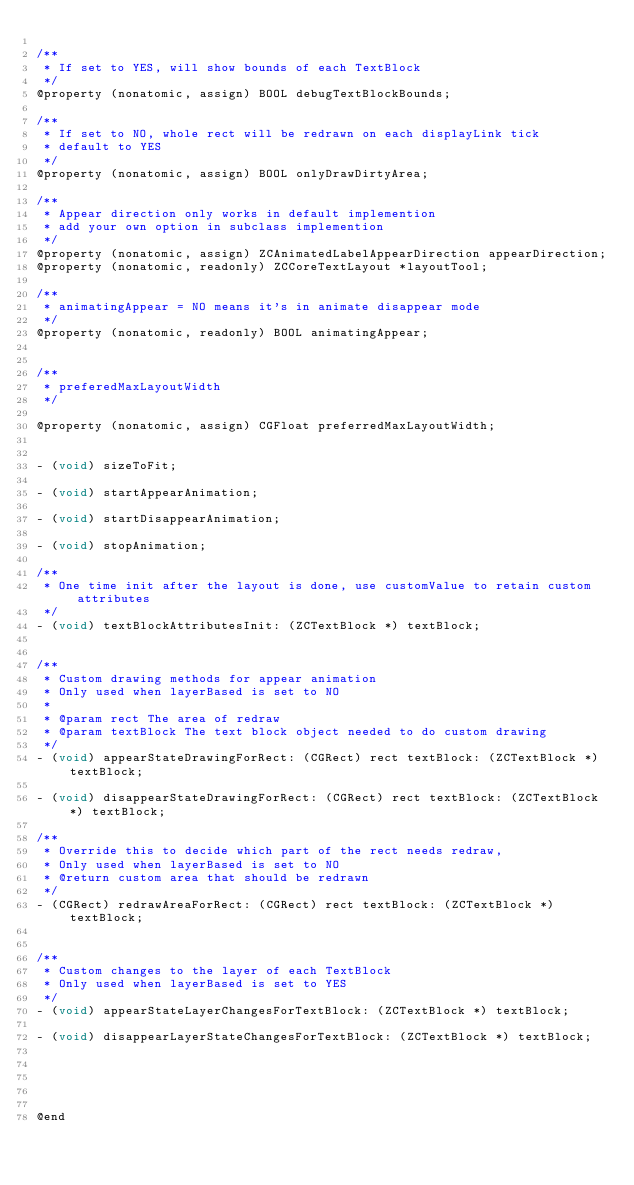Convert code to text. <code><loc_0><loc_0><loc_500><loc_500><_C_>
/**
 * If set to YES, will show bounds of each TextBlock
 */
@property (nonatomic, assign) BOOL debugTextBlockBounds;

/**
 * If set to NO, whole rect will be redrawn on each displayLink tick
 * default to YES
 */
@property (nonatomic, assign) BOOL onlyDrawDirtyArea;

/**
 * Appear direction only works in default implemention
 * add your own option in subclass implemention
 */
@property (nonatomic, assign) ZCAnimatedLabelAppearDirection appearDirection;
@property (nonatomic, readonly) ZCCoreTextLayout *layoutTool;

/**
 * animatingAppear = NO means it's in animate disappear mode
 */
@property (nonatomic, readonly) BOOL animatingAppear;


/**
 * preferedMaxLayoutWidth
 */

@property (nonatomic, assign) CGFloat preferredMaxLayoutWidth;


- (void) sizeToFit;

- (void) startAppearAnimation;

- (void) startDisappearAnimation;

- (void) stopAnimation;

/**
 * One time init after the layout is done, use customValue to retain custom attributes
 */
- (void) textBlockAttributesInit: (ZCTextBlock *) textBlock;


/**
 * Custom drawing methods for appear animation
 * Only used when layerBased is set to NO
 *
 * @param rect The area of redraw
 * @param textBlock The text block object needed to do custom drawing
 */
- (void) appearStateDrawingForRect: (CGRect) rect textBlock: (ZCTextBlock *) textBlock;

- (void) disappearStateDrawingForRect: (CGRect) rect textBlock: (ZCTextBlock *) textBlock;

/**
 * Override this to decide which part of the rect needs redraw,
 * Only used when layerBased is set to NO
 * @return custom area that should be redrawn
 */
- (CGRect) redrawAreaForRect: (CGRect) rect textBlock: (ZCTextBlock *) textBlock;


/**
 * Custom changes to the layer of each TextBlock
 * Only used when layerBased is set to YES
 */
- (void) appearStateLayerChangesForTextBlock: (ZCTextBlock *) textBlock;

- (void) disappearLayerStateChangesForTextBlock: (ZCTextBlock *) textBlock;





@end
</code> 